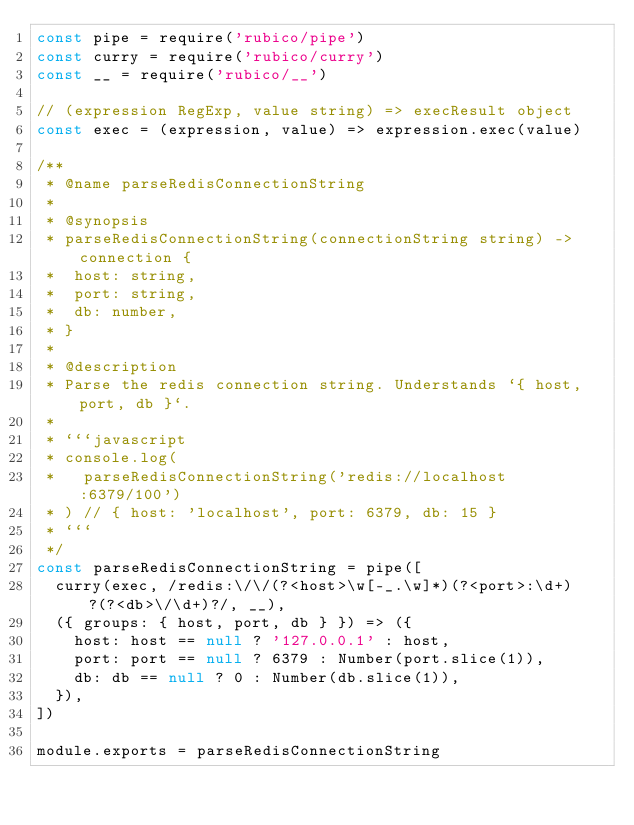Convert code to text. <code><loc_0><loc_0><loc_500><loc_500><_JavaScript_>const pipe = require('rubico/pipe')
const curry = require('rubico/curry')
const __ = require('rubico/__')

// (expression RegExp, value string) => execResult object
const exec = (expression, value) => expression.exec(value)

/**
 * @name parseRedisConnectionString
 *
 * @synopsis
 * parseRedisConnectionString(connectionString string) -> connection {
 *  host: string,
 *  port: string,
 *  db: number,
 * }
 *
 * @description
 * Parse the redis connection string. Understands `{ host, port, db }`.
 *
 * ```javascript
 * console.log(
 *   parseRedisConnectionString('redis://localhost:6379/100')
 * ) // { host: 'localhost', port: 6379, db: 15 }
 * ```
 */
const parseRedisConnectionString = pipe([
  curry(exec, /redis:\/\/(?<host>\w[-_.\w]*)(?<port>:\d+)?(?<db>\/\d+)?/, __),
  ({ groups: { host, port, db } }) => ({
    host: host == null ? '127.0.0.1' : host,
    port: port == null ? 6379 : Number(port.slice(1)),
    db: db == null ? 0 : Number(db.slice(1)),
  }),
])

module.exports = parseRedisConnectionString
</code> 